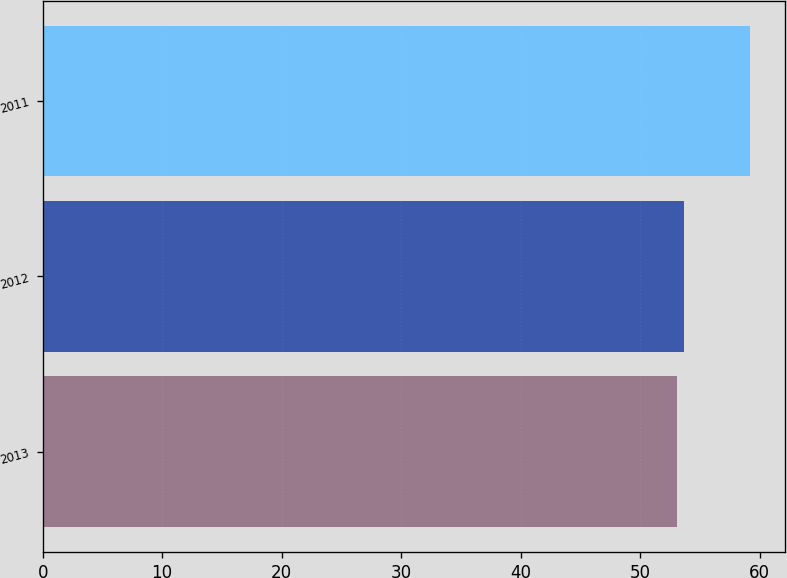<chart> <loc_0><loc_0><loc_500><loc_500><bar_chart><fcel>2013<fcel>2012<fcel>2011<nl><fcel>53.1<fcel>53.71<fcel>59.2<nl></chart> 